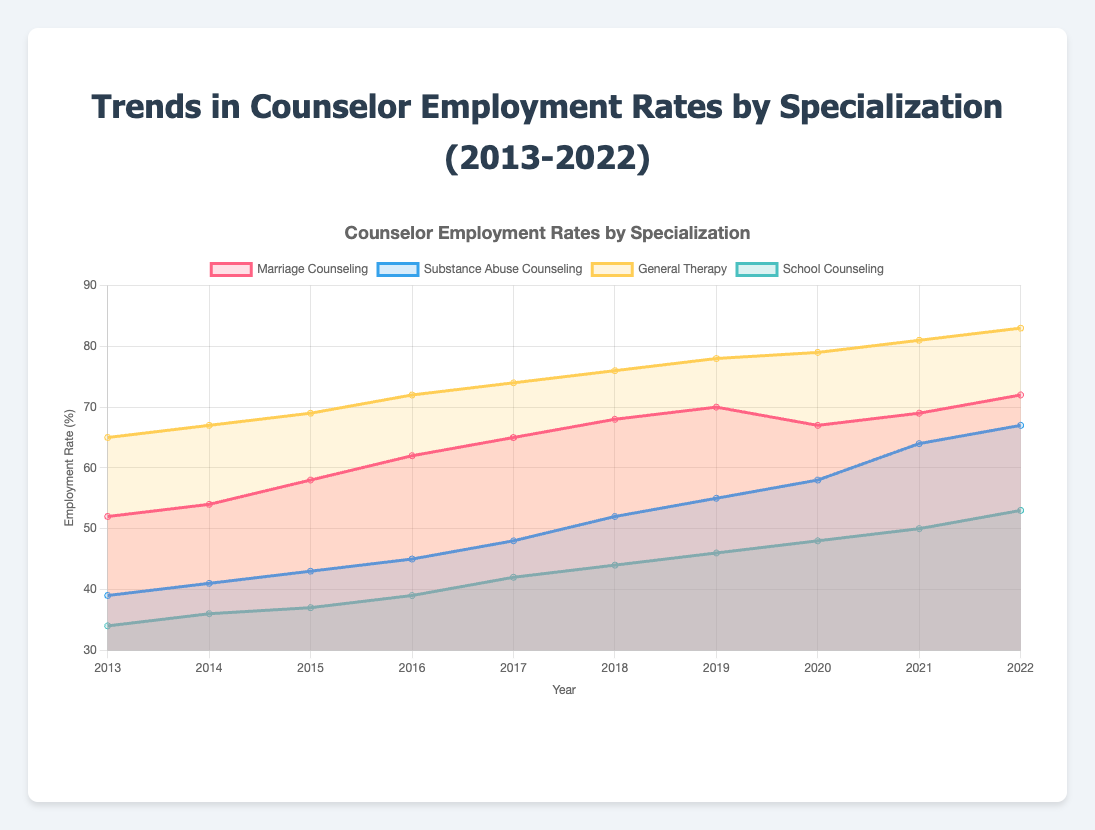What's the title of the figure? The title is displayed at the top of the figure and provides an overview of the data presented in the chart. Here, it is clearly stated in the HTML code where it is set to render the title on the webpage.
Answer: Trends in Counselor Employment Rates by Specialization (2013-2022) What is the employment rate for General Therapy in 2020? Locate the point for General Therapy in the year 2020 on the x-axis and find its corresponding y-value. The data gives an employment rate value directly.
Answer: 79% Which specialization has the highest employment rate in 2022? Look at the data points for 2022 for each specialization and find the highest y-value among them. General Therapy is clearly the highest.
Answer: General Therapy Which specialization has seen the most growth from 2013 to 2022? Calculate the difference between the 2022 and 2013 values for each specialization, and compare them. The highest difference will show the most growth. Substance Abuse Counseling grew from 39% in 2013 to 67% in 2022.
Answer: Substance Abuse Counseling Compare the employment rates of Marriage Counseling and School Counseling in 2018. Which one is higher and by how much? Identify the points for both specializations in 2018 and compare their y-values. Marriage Counseling is at 68%, and School Counseling is at 44%. The difference in their employment rates is 68% - 44%.
Answer: Marriage Counseling, by 24% Has any specialization experienced a decline in employment rates? Review the trends and lines for each specialization. Marriage Counseling shows a small decline between 2019 and 2020.
Answer: Yes, Marriage Counseling between 2019 and 2020 In what year did Substance Abuse Counseling first surpass a 50% employment rate? Check the employment rates of Substance Abuse Counseling in each year. The rate first surpasses 50% in 2018.
Answer: 2018 What's the average employment rate for School Counseling from 2013 to 2022? Sum the yearly employment rates for School Counseling and then divide by the total number of years (10). The values are 34, 36, 37, 39, 42, 44, 46, 48, 50, 53, summing up to 429. The average is 429 / 10.
Answer: 42.9% Which specialization has the least variance in employment rates over the ten years? Calculate the variance for each specialization's employment rates and compare them. General Therapy shows the least fluctuation, steadily increasing each year without large gaps.
Answer: General Therapy 